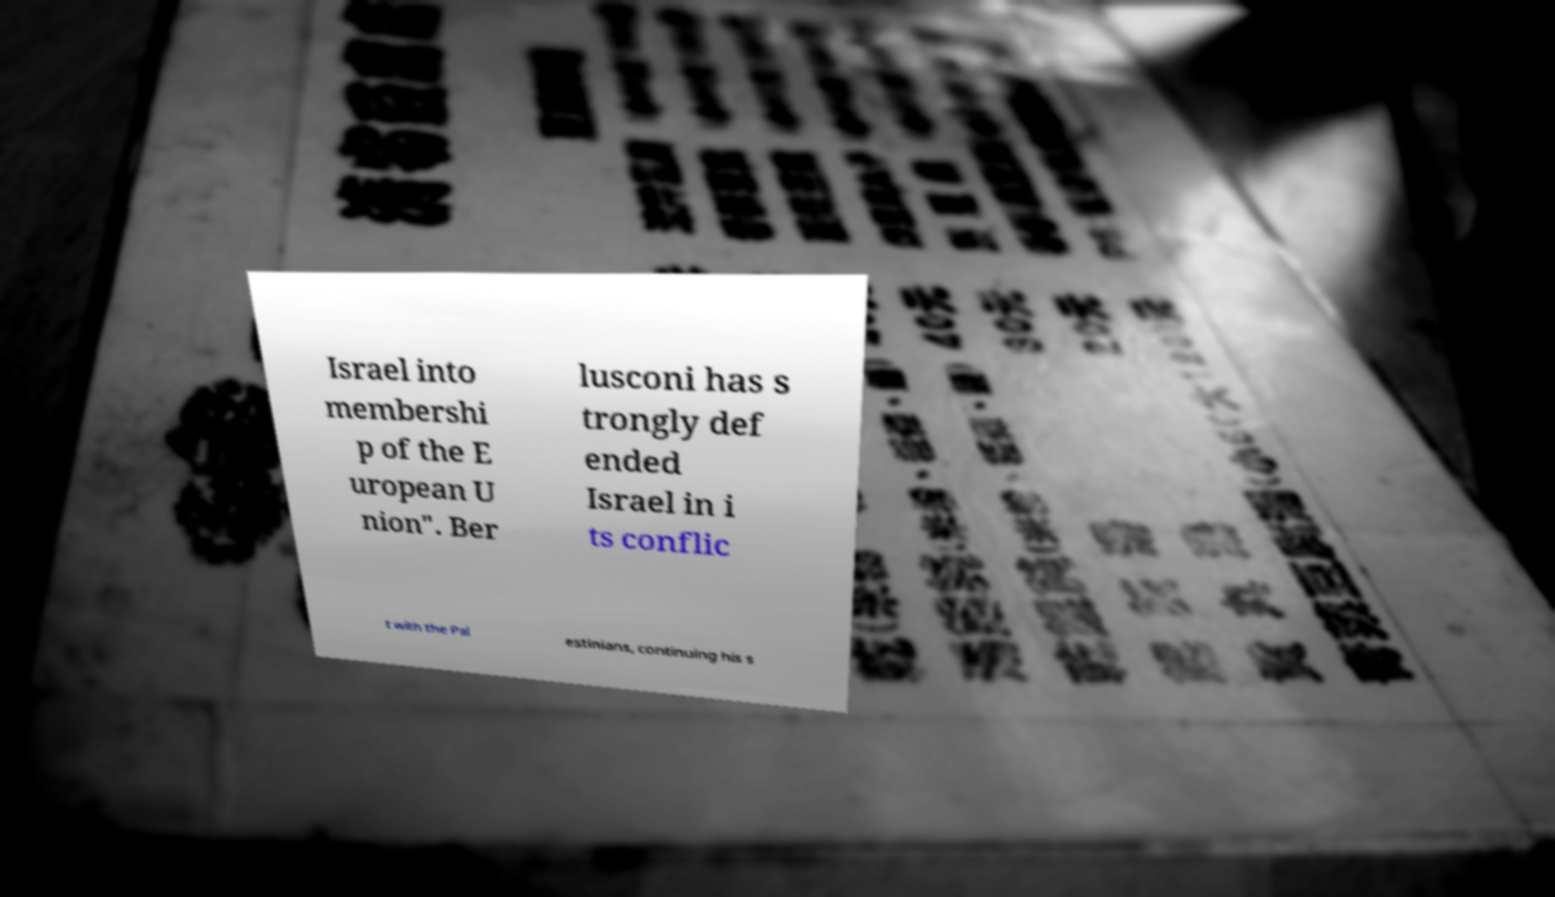Could you assist in decoding the text presented in this image and type it out clearly? Israel into membershi p of the E uropean U nion". Ber lusconi has s trongly def ended Israel in i ts conflic t with the Pal estinians, continuing his s 